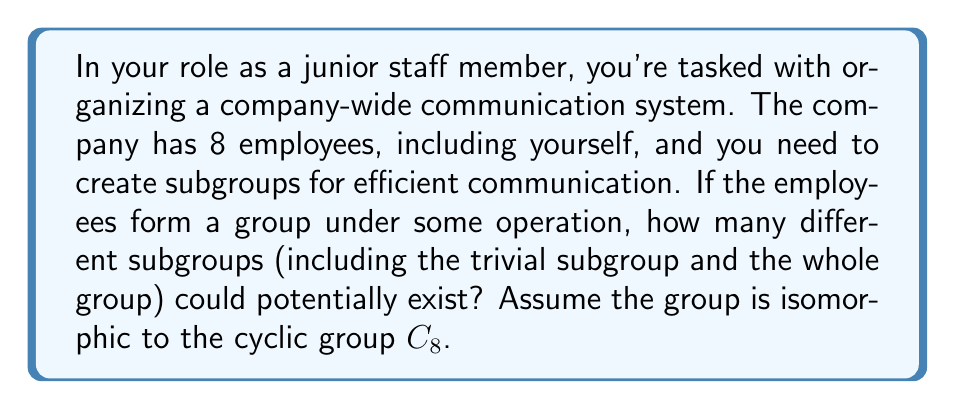Help me with this question. To solve this problem, we need to understand the structure of cyclic groups and their subgroups. Let's approach this step-by-step:

1) The group in question is isomorphic to $C_8$, the cyclic group of order 8.

2) In a cyclic group, the number of subgroups is equal to the number of divisors of the group's order.

3) The divisors of 8 are: 1, 2, 4, and 8.

4) For each divisor $d$ of 8, there is exactly one subgroup of order $d$.

5) Let's list these subgroups:
   - Order 1: The trivial subgroup $\{e\}$
   - Order 2: $\{e, a^4\}$, where $a$ is a generator of $C_8$
   - Order 4: $\{e, a^2, a^4, a^6\}$
   - Order 8: The whole group $C_8$

6) Therefore, the total number of subgroups is equal to the number of divisors of 8, which is 4.

This structure ensures that communication can be organized in various levels of inclusivity, from one-on-one (trivial subgroup) to the entire company (whole group), with two intermediate levels for smaller team discussions.
Answer: 4 subgroups 